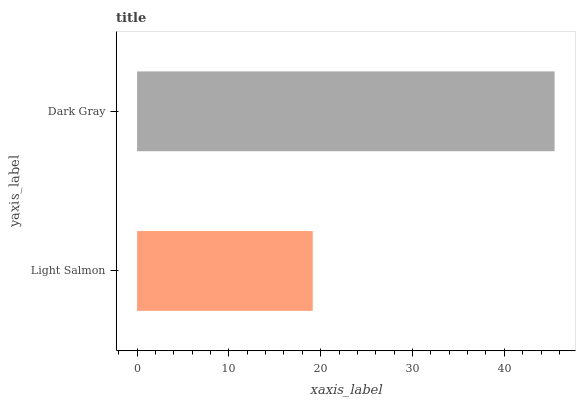Is Light Salmon the minimum?
Answer yes or no. Yes. Is Dark Gray the maximum?
Answer yes or no. Yes. Is Dark Gray the minimum?
Answer yes or no. No. Is Dark Gray greater than Light Salmon?
Answer yes or no. Yes. Is Light Salmon less than Dark Gray?
Answer yes or no. Yes. Is Light Salmon greater than Dark Gray?
Answer yes or no. No. Is Dark Gray less than Light Salmon?
Answer yes or no. No. Is Dark Gray the high median?
Answer yes or no. Yes. Is Light Salmon the low median?
Answer yes or no. Yes. Is Light Salmon the high median?
Answer yes or no. No. Is Dark Gray the low median?
Answer yes or no. No. 